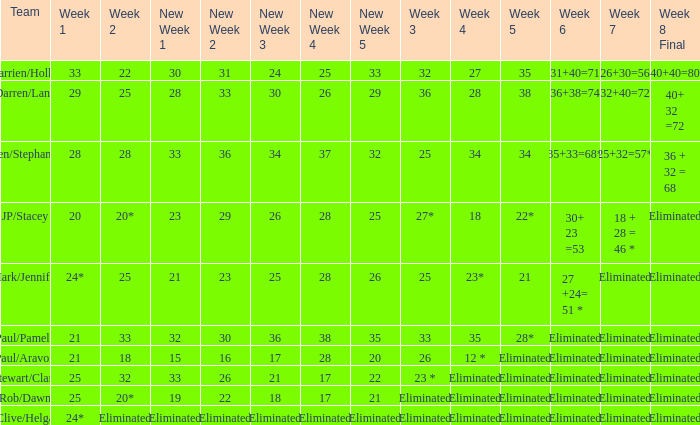Name the team for week 1 of 28 Ben/Stephanie. 